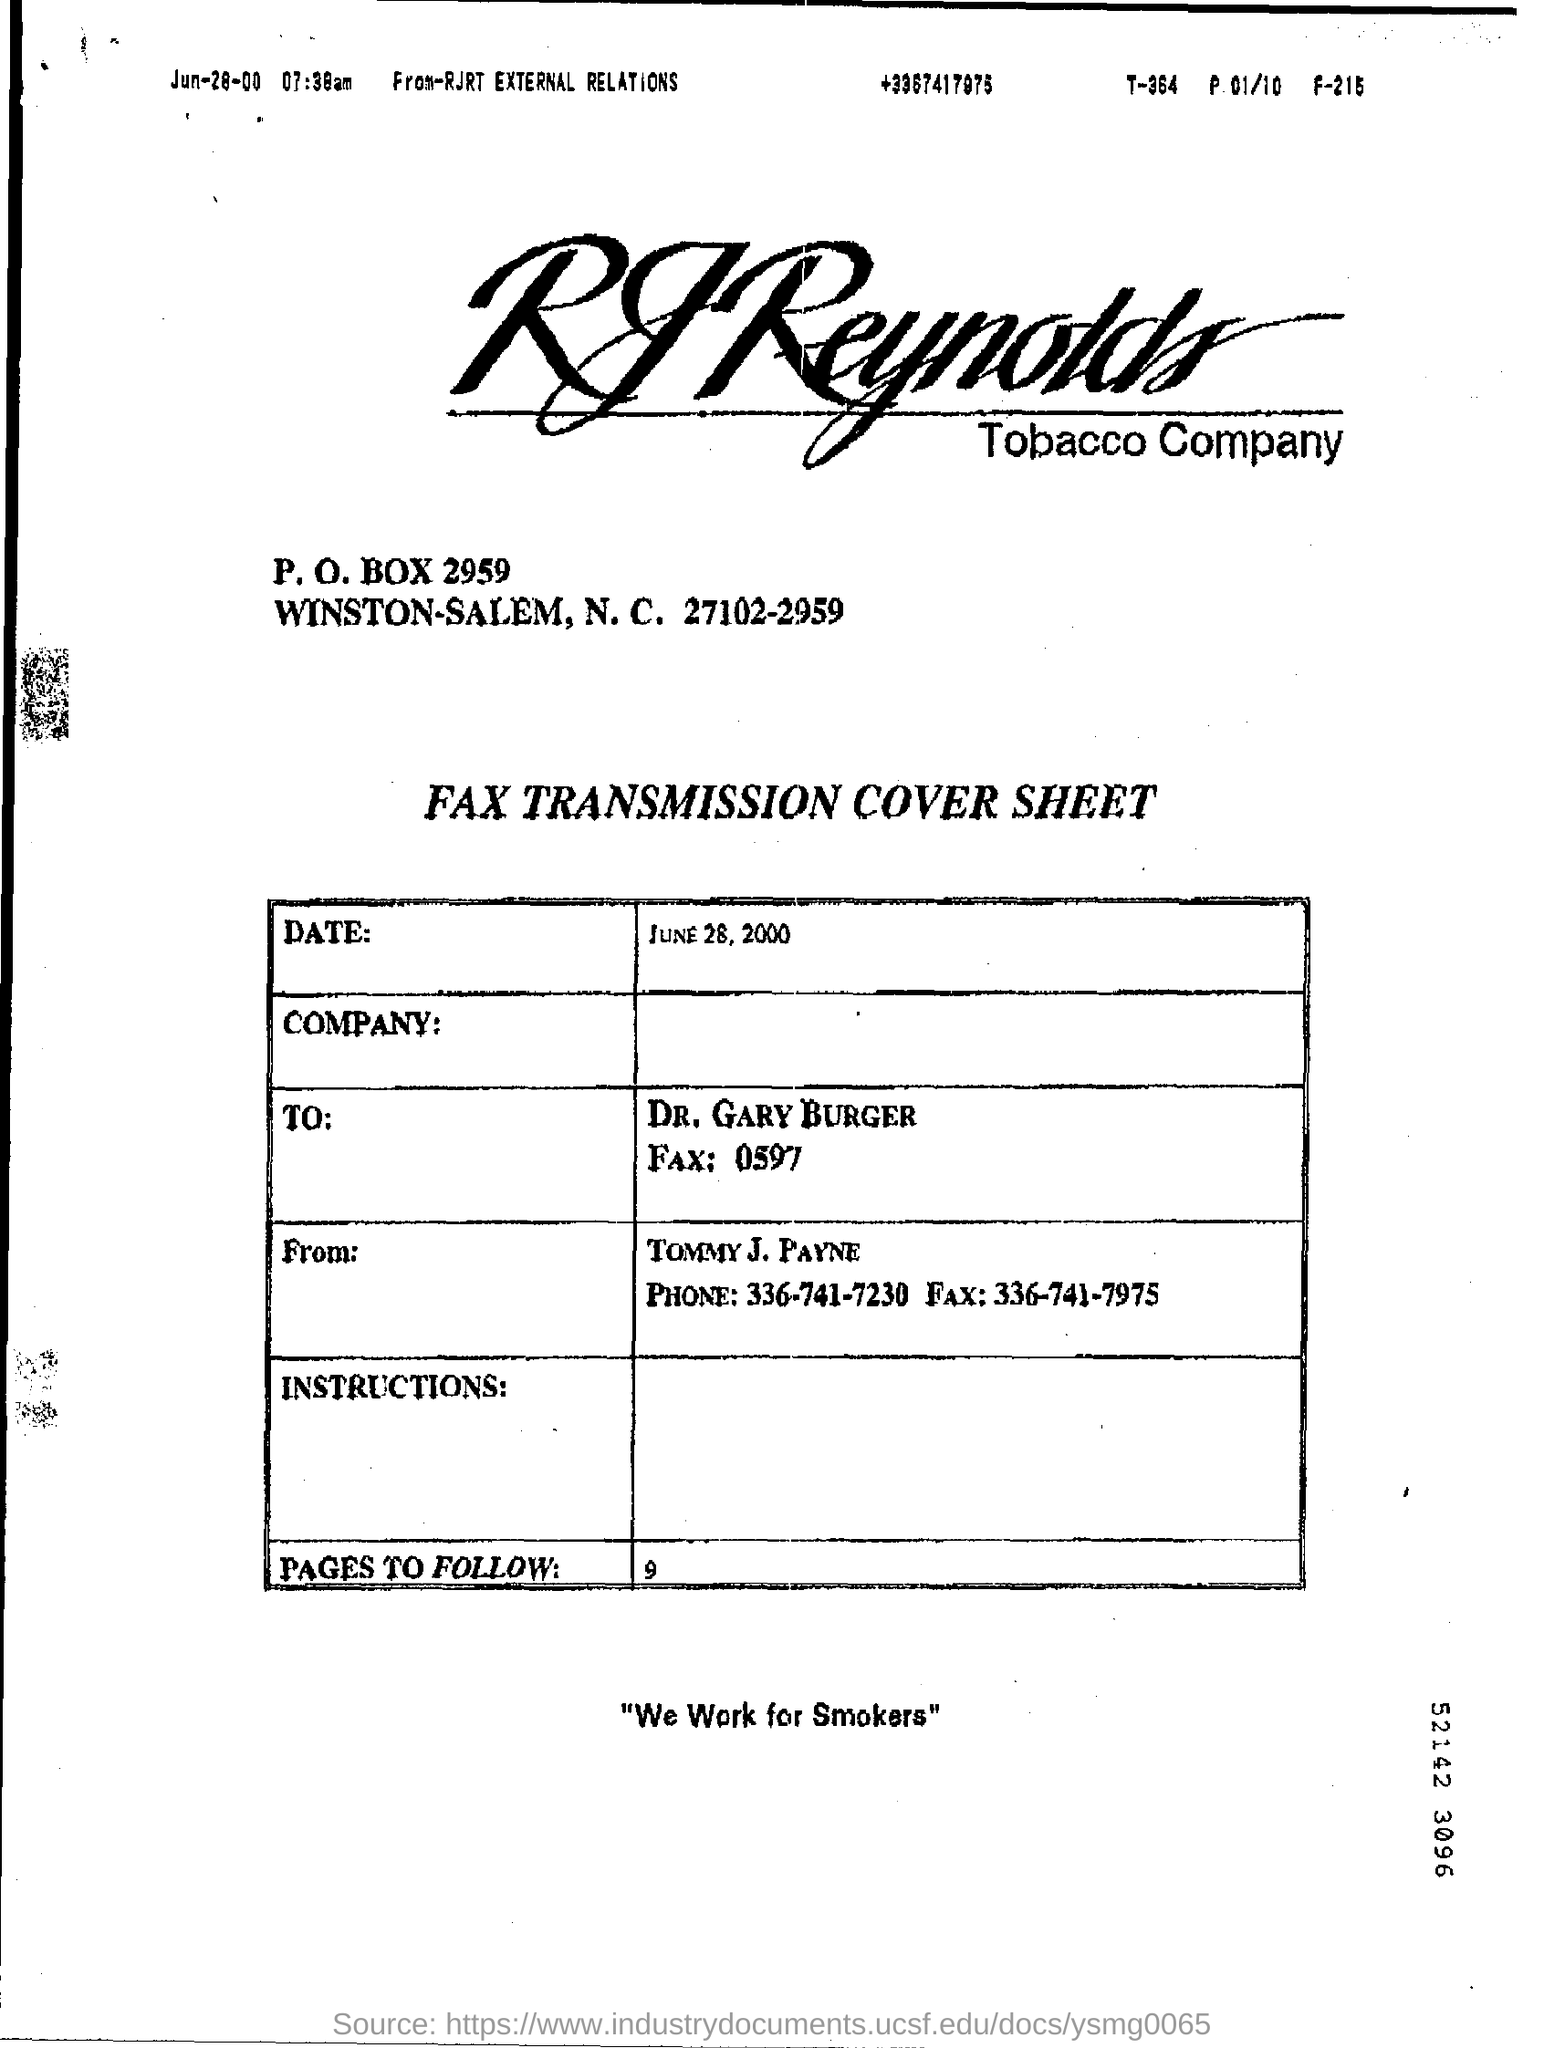Who is the sender of the Fax?
Your answer should be compact. Tommy J. Payne. What is the Fax No of Tommy J. Payne?
Keep it short and to the point. 336-741-7975. Who is the receiver of the Fax?
Give a very brief answer. DR. GARY BURGER. What are the no of pages to follow ?
Your answer should be compact. 9. 